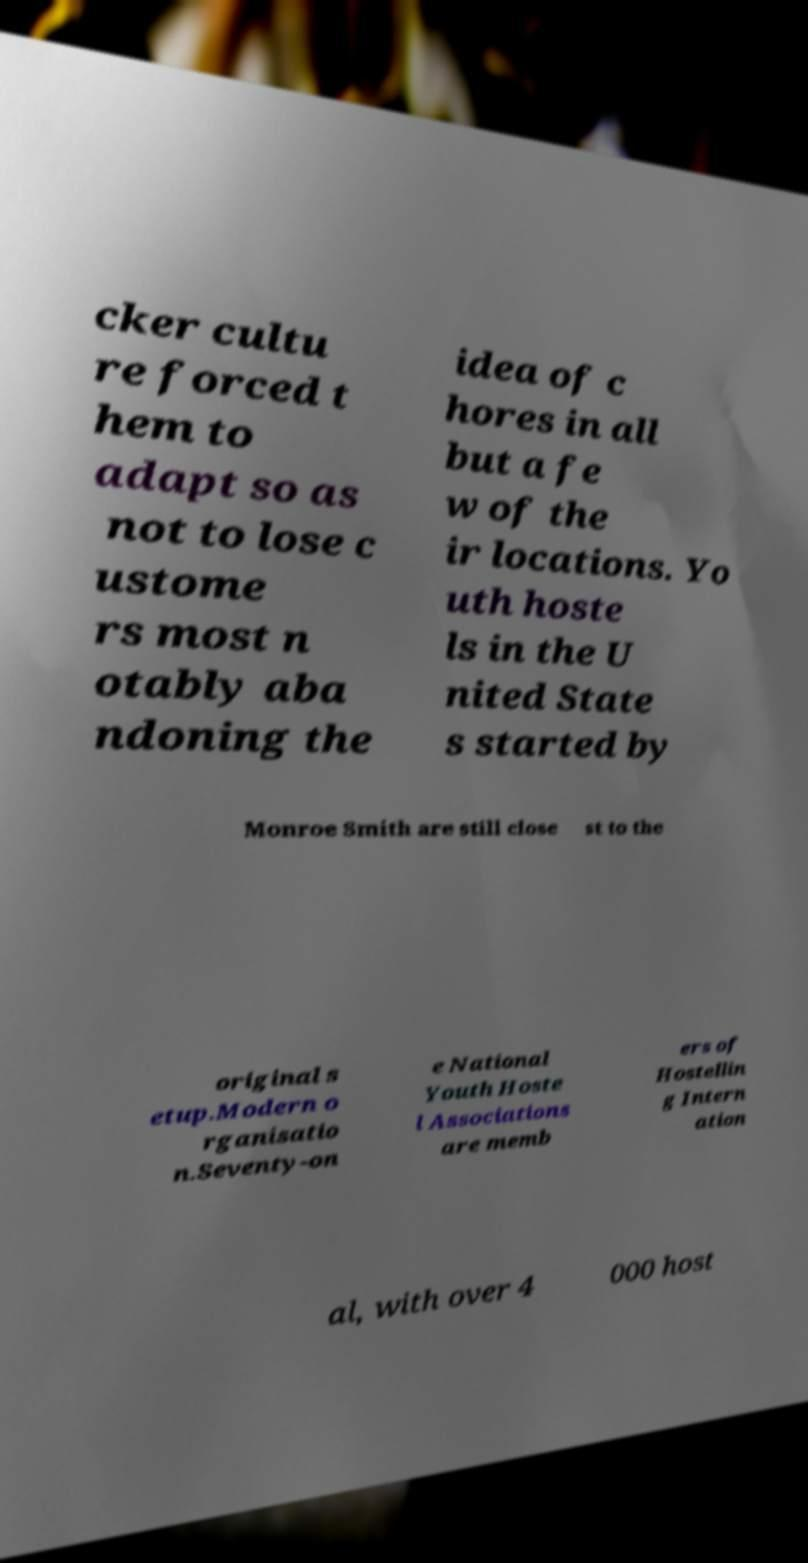Please read and relay the text visible in this image. What does it say? cker cultu re forced t hem to adapt so as not to lose c ustome rs most n otably aba ndoning the idea of c hores in all but a fe w of the ir locations. Yo uth hoste ls in the U nited State s started by Monroe Smith are still close st to the original s etup.Modern o rganisatio n.Seventy-on e National Youth Hoste l Associations are memb ers of Hostellin g Intern ation al, with over 4 000 host 